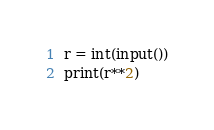<code> <loc_0><loc_0><loc_500><loc_500><_Python_>r = int(input())
print(r**2)</code> 